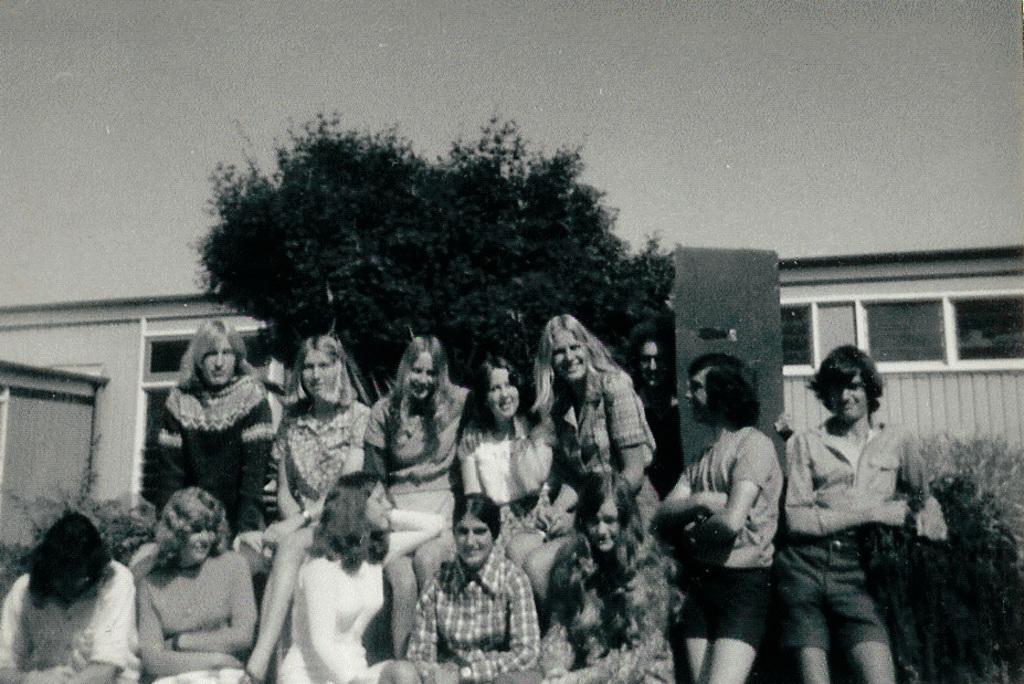Could you give a brief overview of what you see in this image? In the image we can see there are women sitting and there are two women standing. Behind there are trees and there is a building. There is a clear sky. 